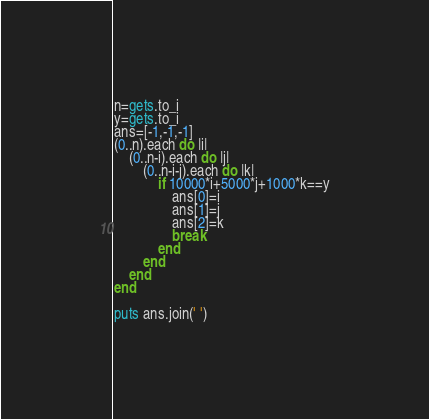Convert code to text. <code><loc_0><loc_0><loc_500><loc_500><_Ruby_>n=gets.to_i
y=gets.to_i
ans=[-1,-1,-1]
(0..n).each do |i|
    (0..n-i).each do |j|
        (0..n-i-j).each do |k|
            if 10000*i+5000*j+1000*k==y
                ans[0]=i
                ans[1]=j
                ans[2]=k
                break
            end
        end
    end
end

puts ans.join(' ')</code> 